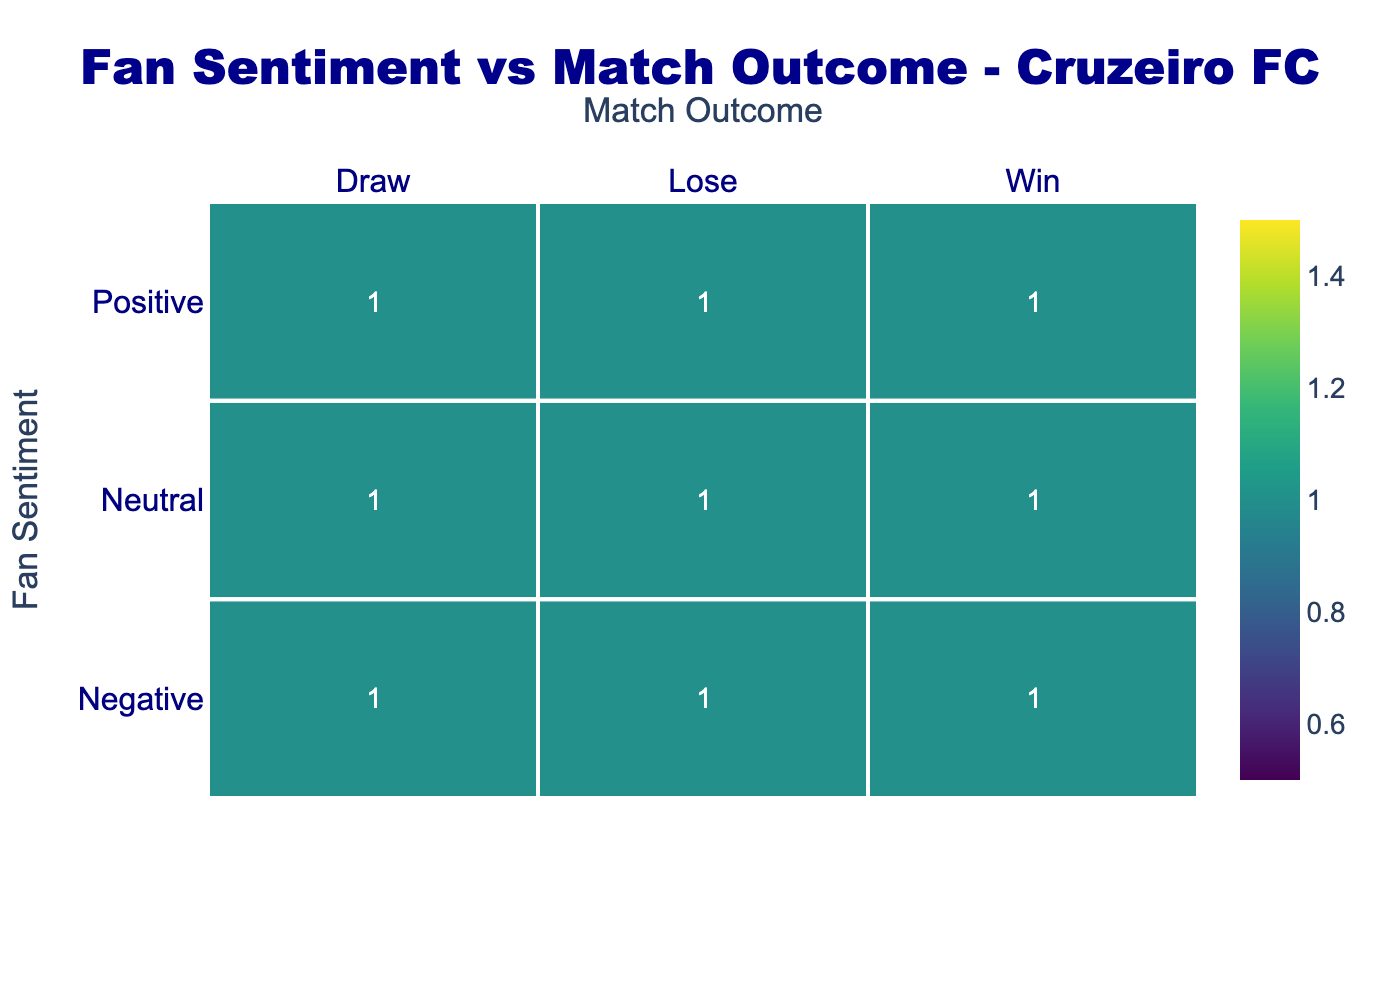What is the count of fans with negative sentiment who experienced a loss? In the confusion matrix, we need to look at the intersection of "Negative" sentiment and "Lose" match outcome. Referring to the matrix, this count is 1.
Answer: 1 How many total match outcomes are represented in the table? The match outcomes consist of "Win", "Draw", and "Lose", which gives us a total of 3 unique outcomes. Each sentiment—Positive, Negative, and Neutral—correlates with each of these outcomes. Therefore, the total number of match outcomes represented is 9 (3 outcomes x 3 sentiments).
Answer: 9 What percentage of total match outcomes resulted in a win? From the total of 9 outcomes, 4 resulted in a win (2 from Positive, 1 from Negative, and 1 from Neutral). The percentage calculation is (4/9) * 100 ≈ 44.44%.
Answer: 44.44% Is it true that fans with neutral sentiment were more likely to experience a draw than a loss? Looking at the counts, Neutral sentiment resulted in 1 Draw and 1 Lose. Since the counts are equal, it is false that draws were more likely compared to losses for Neutral sentiment.
Answer: No What is the difference in counts between positive sentiment wins and negative sentiment wins? The count of positive sentiment wins is 2 and the count of negative sentiment wins is 1. The difference is calculated as 2 - 1 = 1.
Answer: 1 What is the most common match outcome for fans with a positive sentiment? Referring to the confusion matrix, positive sentiment correlates with 2 wins, 1 draw, and 1 loss. The most common match outcome is a Win with a count of 2.
Answer: Win How many total fans experienced a neutral sentiment in the matrix? From the table, we know the counts for Neutral sentiment are distributed across 3 outcomes: Win, Draw, and Lose, with 1 each. Therefore, the total count of fans with Neutral sentiment is 1 + 1 + 1 = 3.
Answer: 3 Was the sentiment of fans negatively impacted more during losses compared to draws? In the matrix, negative sentiment corresponds to 1 outcome each for draws and losses. Since the counts are equal, it indicates that negative sentiment was not more impacted during losses compared to draws.
Answer: No 